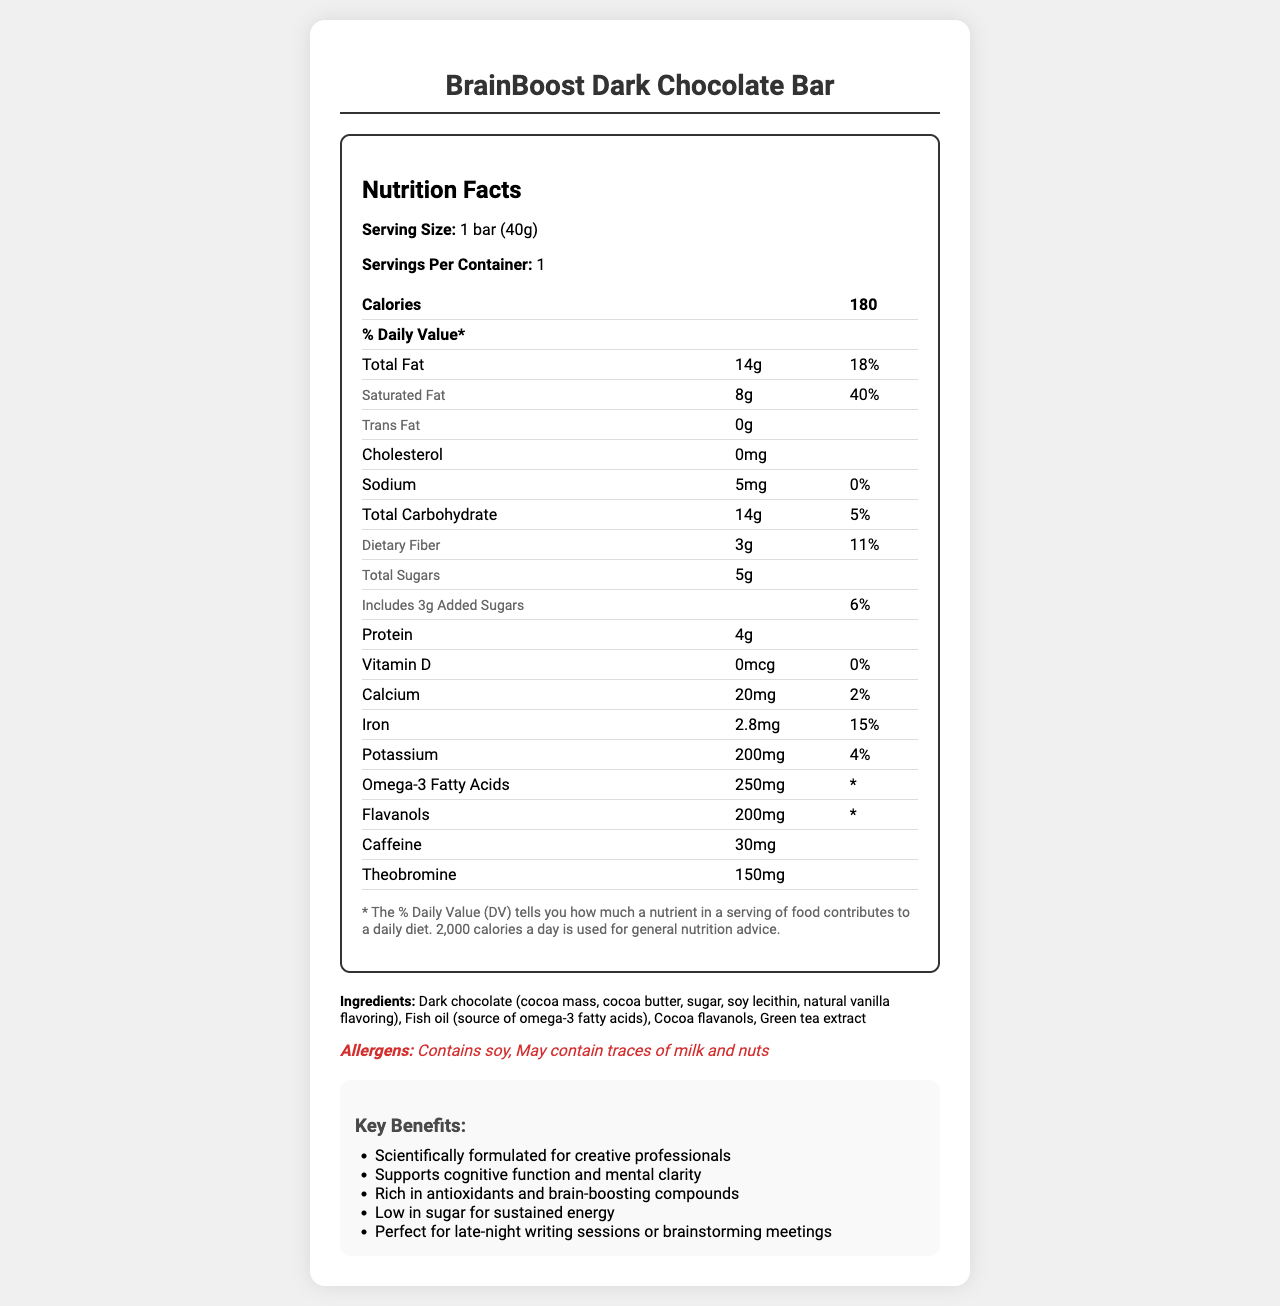What is the serving size of the BrainBoost Dark Chocolate Bar? The serving size is clearly mentioned in the Nutrition Facts section as "1 bar (40g)".
Answer: 1 bar (40g) How many calories are in one serving of the BrainBoost Dark Chocolate Bar? The Nutrition Facts section lists the calorie content as 180 calories per serving.
Answer: 180 How much protein does the BrainBoost Dark Chocolate Bar contain? The protein content is listed as 4g in the Nutrition Facts section.
Answer: 4g What is the amount of omega-3 fatty acids in the BrainBoost Dark Chocolate Bar? The Nutrition Facts section shows that the bar contains 250mg of omega-3 fatty acids.
Answer: 250mg What is the total fat content in the BrainBoost Dark Chocolate Bar? The total fat is listed as 14g in the Nutrition Facts section.
Answer: 14g Which of the following is a key ingredient in the BrainBoost Dark Chocolate Bar? A. Almonds B. Green tea extract C. Whey protein Green tea extract is mentioned in the ingredients list, while almonds and whey protein are not.
Answer: B How many grams of dietary fiber are in the BrainBoost Dark Chocolate Bar? The Nutrition Facts section indicates that the bar contains 3g of dietary fiber.
Answer: 3g True or False: The BrainBoost Dark Chocolate Bar contains trans fat. The Nutrition Facts section reveals that the bar contains 0g of trans fat.
Answer: False What is one potential storyline suggested for using the BrainBoost Dark Chocolate Bar in a TV show? The TV producer notes include potential use in a storyline about a character’s obsession with brain-enhancing foods.
Answer: A storyline involving a health-conscious character's obsession with brain-enhancing foods Summarize the main idea of this document. The document includes nutritional facts, key ingredients, marketing claims, and notes on potential TV story arcs related to the BrainBoost Dark Chocolate Bar.
Answer: The document provides detailed nutritional information about the BrainBoost Dark Chocolate Bar, emphasizing its benefits for creative professionals with its low sugar content, brain-boosting ingredients like omega-3 fatty acids, and antioxidants. Additionally, it includes potential uses for the bar in TV storylines. Who is the BrainBoost Dark Chocolate Bar marketed towards? The marketing claims explicitly state that the bar is "Scientifically formulated for creative professionals."
Answer: Creative professionals What is the percentage daily value of saturated fat in the BrainBoost Dark Chocolate Bar? The Nutrition Facts section lists the daily value of saturated fat as 40%.
Answer: 40% Which of the following is NOT a marketing claim of the BrainBoost Dark Chocolate Bar? A. Supports cognitive function and mental clarity B. Contains zero calories C. Low in sugar for sustained energy "Contains zero calories" is not mentioned in the marketing claims.
Answer: B Can the BrainBoost Dark Chocolate Bar be safely consumed by someone with a nut allergy? While the bar contains soy and may contain traces of milk and nuts, it's unclear if these traces would affect someone with a nut allergy without further information.
Answer: Not enough information What is the total amount of sugars in one serving of the BrainBoost Dark Chocolate Bar? The total sugars are listed as 5g in the Nutrition Facts section.
Answer: 5g 